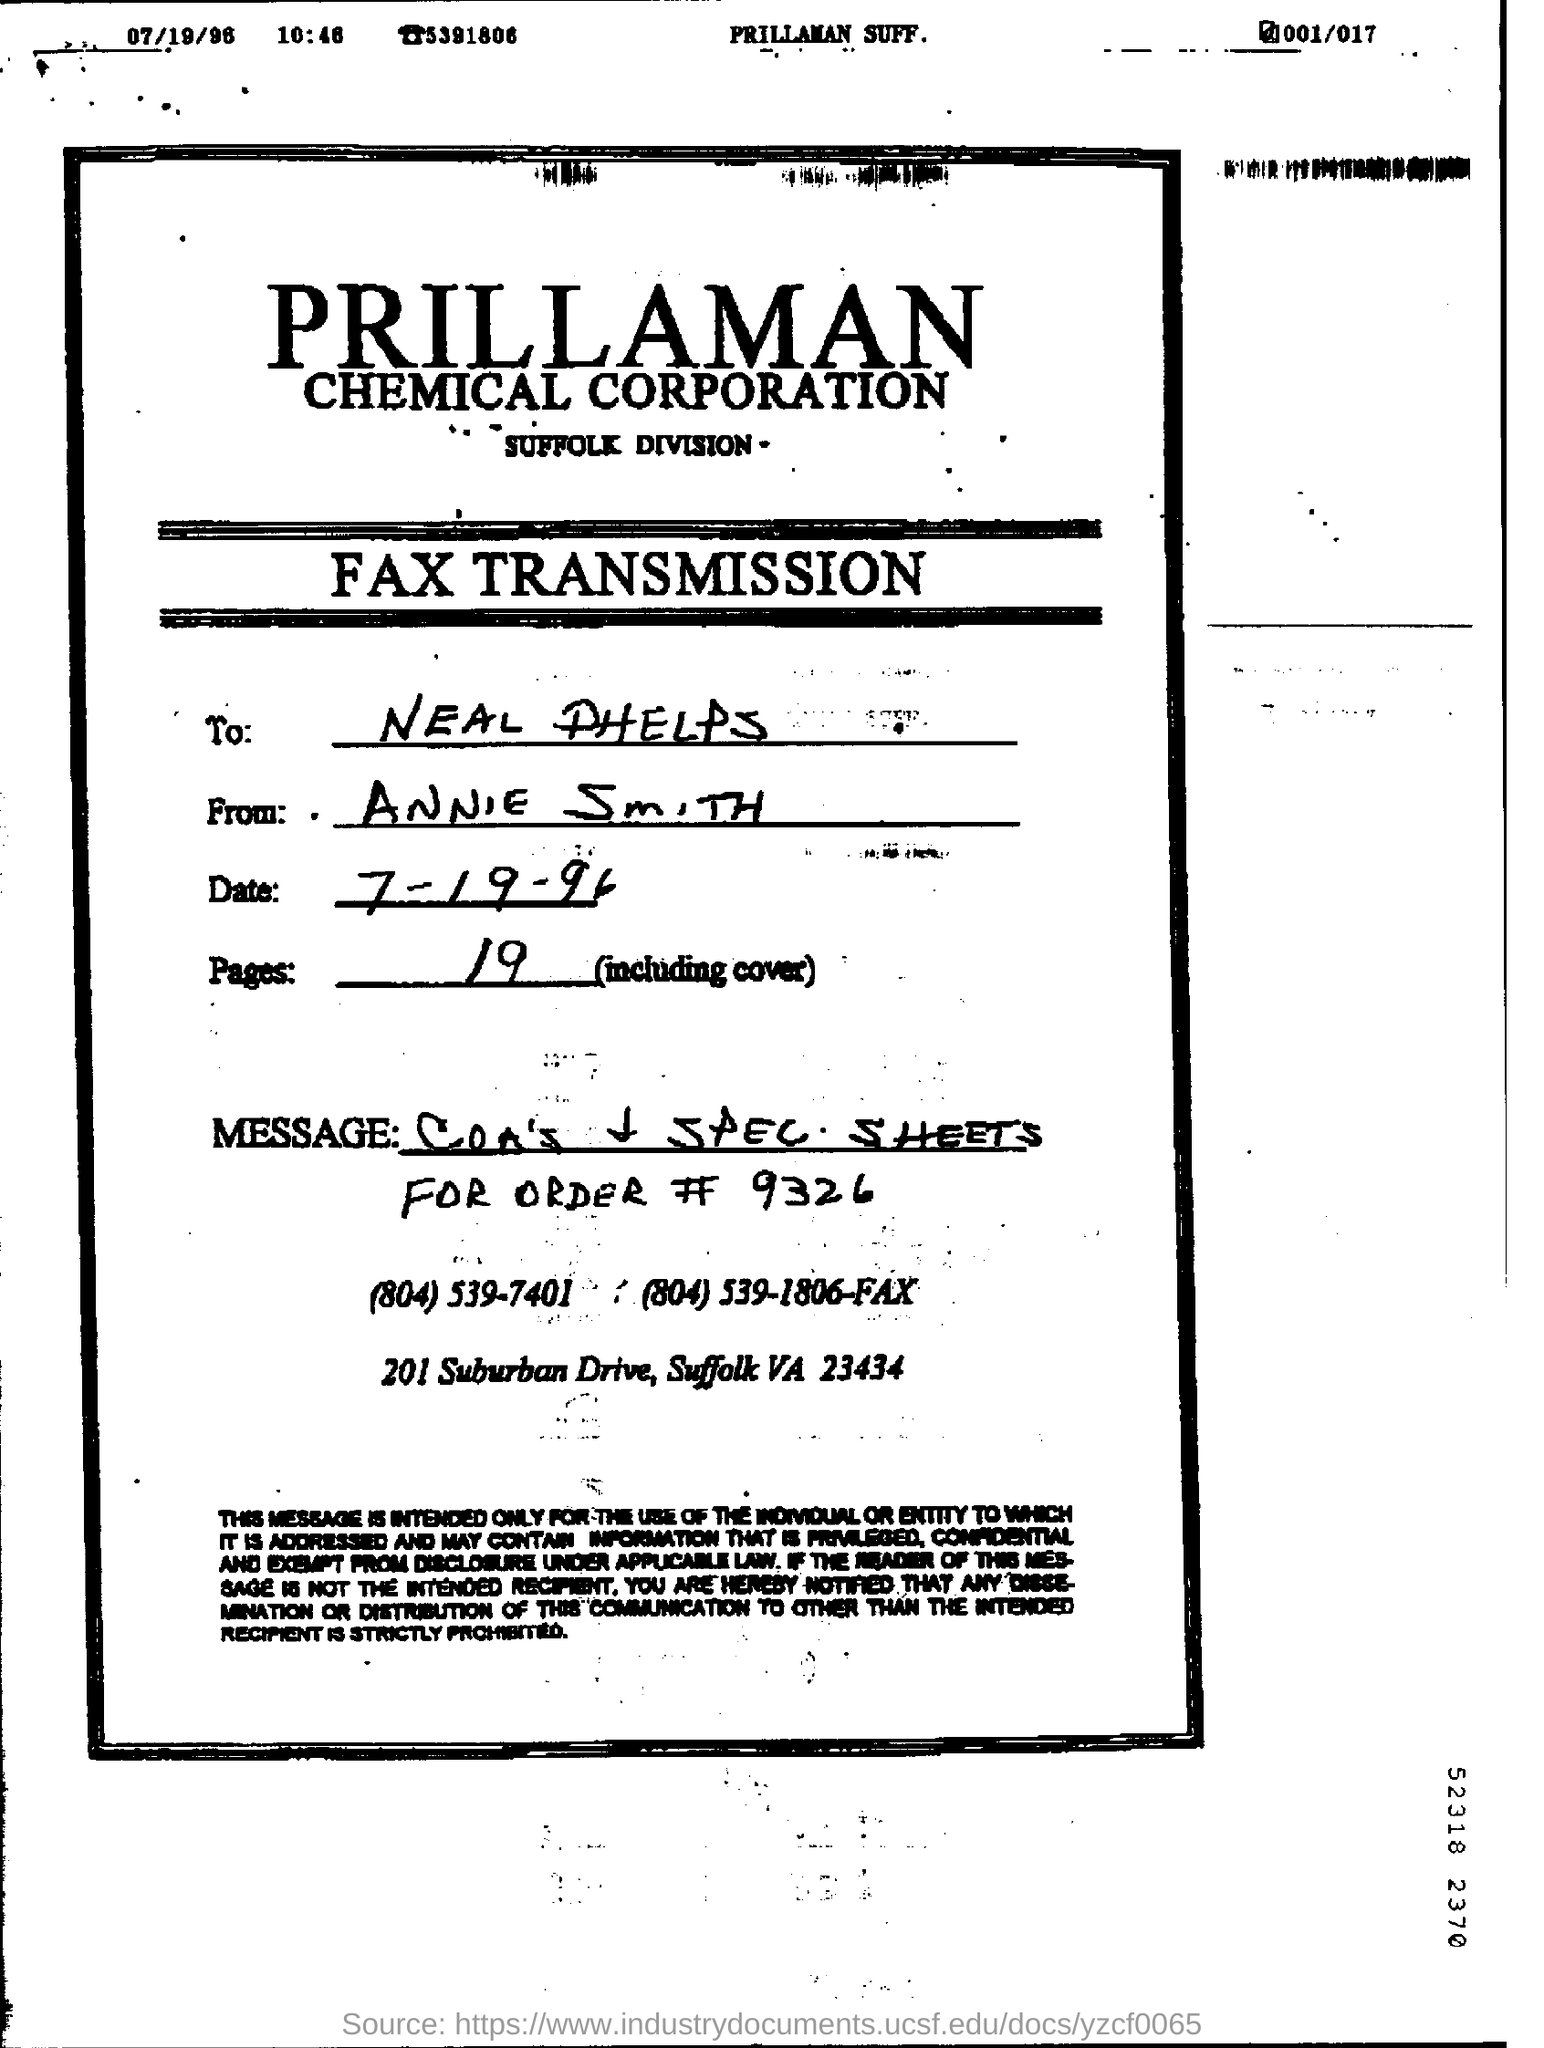Point out several critical features in this image. The letter is from Annie Smith. 